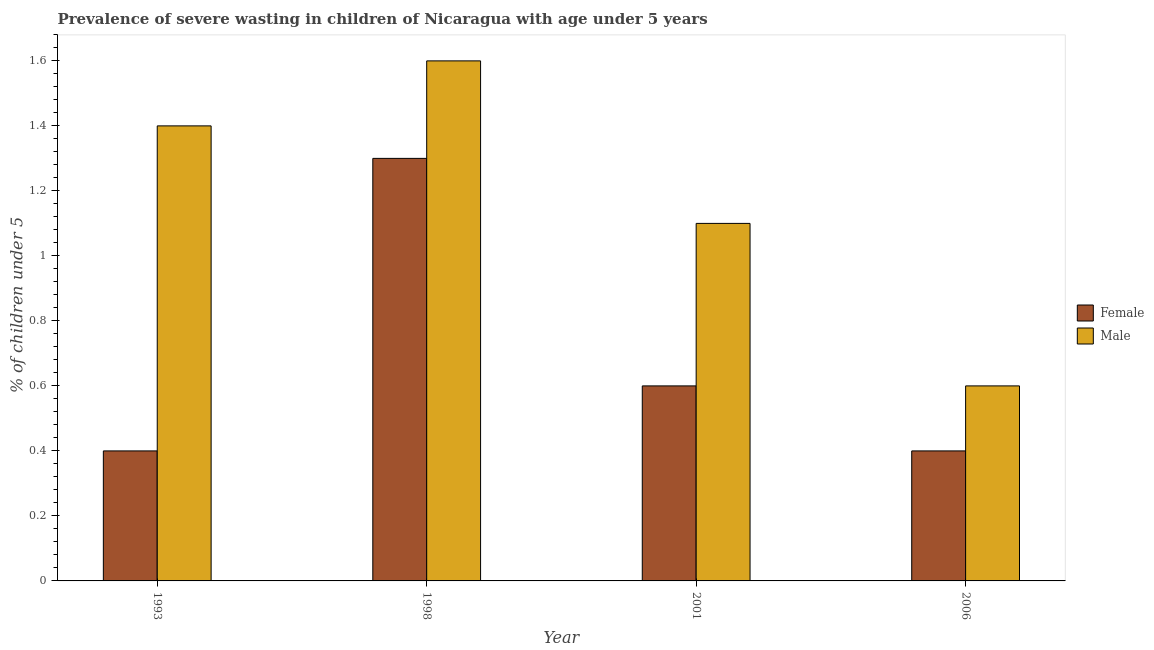How many different coloured bars are there?
Ensure brevity in your answer.  2. Are the number of bars on each tick of the X-axis equal?
Your response must be concise. Yes. In how many cases, is the number of bars for a given year not equal to the number of legend labels?
Your response must be concise. 0. What is the percentage of undernourished female children in 2006?
Give a very brief answer. 0.4. Across all years, what is the maximum percentage of undernourished male children?
Give a very brief answer. 1.6. Across all years, what is the minimum percentage of undernourished male children?
Ensure brevity in your answer.  0.6. In which year was the percentage of undernourished male children maximum?
Keep it short and to the point. 1998. What is the total percentage of undernourished male children in the graph?
Make the answer very short. 4.7. What is the difference between the percentage of undernourished female children in 1998 and that in 2001?
Offer a very short reply. 0.7. What is the difference between the percentage of undernourished male children in 1993 and the percentage of undernourished female children in 2006?
Provide a short and direct response. 0.8. What is the average percentage of undernourished female children per year?
Provide a succinct answer. 0.67. In the year 2006, what is the difference between the percentage of undernourished female children and percentage of undernourished male children?
Provide a succinct answer. 0. In how many years, is the percentage of undernourished male children greater than 1.56 %?
Your answer should be very brief. 1. What is the ratio of the percentage of undernourished female children in 1993 to that in 2001?
Your answer should be very brief. 0.67. Is the percentage of undernourished female children in 1998 less than that in 2006?
Make the answer very short. No. Is the difference between the percentage of undernourished female children in 1998 and 2001 greater than the difference between the percentage of undernourished male children in 1998 and 2001?
Provide a succinct answer. No. What is the difference between the highest and the second highest percentage of undernourished female children?
Provide a short and direct response. 0.7. What is the difference between the highest and the lowest percentage of undernourished female children?
Your response must be concise. 0.9. In how many years, is the percentage of undernourished male children greater than the average percentage of undernourished male children taken over all years?
Offer a very short reply. 2. What does the 2nd bar from the left in 2006 represents?
Your answer should be compact. Male. What does the 2nd bar from the right in 2006 represents?
Offer a terse response. Female. How many bars are there?
Keep it short and to the point. 8. Are all the bars in the graph horizontal?
Provide a succinct answer. No. What is the difference between two consecutive major ticks on the Y-axis?
Your response must be concise. 0.2. Does the graph contain grids?
Provide a succinct answer. No. What is the title of the graph?
Provide a succinct answer. Prevalence of severe wasting in children of Nicaragua with age under 5 years. What is the label or title of the Y-axis?
Your answer should be very brief.  % of children under 5. What is the  % of children under 5 of Female in 1993?
Provide a short and direct response. 0.4. What is the  % of children under 5 in Male in 1993?
Ensure brevity in your answer.  1.4. What is the  % of children under 5 of Female in 1998?
Give a very brief answer. 1.3. What is the  % of children under 5 of Male in 1998?
Your response must be concise. 1.6. What is the  % of children under 5 in Female in 2001?
Provide a short and direct response. 0.6. What is the  % of children under 5 of Male in 2001?
Offer a very short reply. 1.1. What is the  % of children under 5 of Female in 2006?
Offer a terse response. 0.4. What is the  % of children under 5 of Male in 2006?
Your answer should be very brief. 0.6. Across all years, what is the maximum  % of children under 5 of Female?
Offer a very short reply. 1.3. Across all years, what is the maximum  % of children under 5 in Male?
Give a very brief answer. 1.6. Across all years, what is the minimum  % of children under 5 in Female?
Offer a very short reply. 0.4. Across all years, what is the minimum  % of children under 5 of Male?
Provide a short and direct response. 0.6. What is the total  % of children under 5 of Male in the graph?
Ensure brevity in your answer.  4.7. What is the difference between the  % of children under 5 of Male in 1993 and that in 1998?
Ensure brevity in your answer.  -0.2. What is the difference between the  % of children under 5 of Female in 1993 and that in 2006?
Ensure brevity in your answer.  0. What is the difference between the  % of children under 5 in Male in 1993 and that in 2006?
Ensure brevity in your answer.  0.8. What is the difference between the  % of children under 5 of Male in 1998 and that in 2001?
Your answer should be very brief. 0.5. What is the difference between the  % of children under 5 in Female in 1998 and that in 2006?
Your response must be concise. 0.9. What is the difference between the  % of children under 5 of Female in 2001 and that in 2006?
Ensure brevity in your answer.  0.2. What is the difference between the  % of children under 5 in Female in 1993 and the  % of children under 5 in Male in 2001?
Your response must be concise. -0.7. What is the difference between the  % of children under 5 of Female in 2001 and the  % of children under 5 of Male in 2006?
Your answer should be compact. 0. What is the average  % of children under 5 in Female per year?
Make the answer very short. 0.68. What is the average  % of children under 5 of Male per year?
Provide a short and direct response. 1.18. In the year 2001, what is the difference between the  % of children under 5 in Female and  % of children under 5 in Male?
Offer a very short reply. -0.5. What is the ratio of the  % of children under 5 of Female in 1993 to that in 1998?
Make the answer very short. 0.31. What is the ratio of the  % of children under 5 of Male in 1993 to that in 1998?
Offer a terse response. 0.88. What is the ratio of the  % of children under 5 of Female in 1993 to that in 2001?
Your answer should be compact. 0.67. What is the ratio of the  % of children under 5 in Male in 1993 to that in 2001?
Ensure brevity in your answer.  1.27. What is the ratio of the  % of children under 5 in Female in 1993 to that in 2006?
Provide a short and direct response. 1. What is the ratio of the  % of children under 5 in Male in 1993 to that in 2006?
Keep it short and to the point. 2.33. What is the ratio of the  % of children under 5 of Female in 1998 to that in 2001?
Your answer should be compact. 2.17. What is the ratio of the  % of children under 5 in Male in 1998 to that in 2001?
Provide a short and direct response. 1.45. What is the ratio of the  % of children under 5 in Female in 1998 to that in 2006?
Give a very brief answer. 3.25. What is the ratio of the  % of children under 5 of Male in 1998 to that in 2006?
Your response must be concise. 2.67. What is the ratio of the  % of children under 5 of Male in 2001 to that in 2006?
Give a very brief answer. 1.83. What is the difference between the highest and the second highest  % of children under 5 in Female?
Offer a very short reply. 0.7. What is the difference between the highest and the second highest  % of children under 5 in Male?
Provide a succinct answer. 0.2. What is the difference between the highest and the lowest  % of children under 5 of Female?
Give a very brief answer. 0.9. 